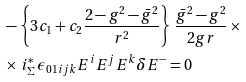Convert formula to latex. <formula><loc_0><loc_0><loc_500><loc_500>& - \left \{ 3 c _ { 1 } + c _ { 2 } \frac { 2 - g ^ { 2 } - \bar { g } ^ { 2 } } { r ^ { 2 } } \right \} \, \frac { \bar { g } ^ { 2 } - g ^ { 2 } } { 2 g r } \, \times \\ & \times \, i ^ { * } _ { \Sigma } \, \epsilon _ { 0 1 i j k } E ^ { i } E ^ { j } E ^ { k } \delta E ^ { - } = 0</formula> 